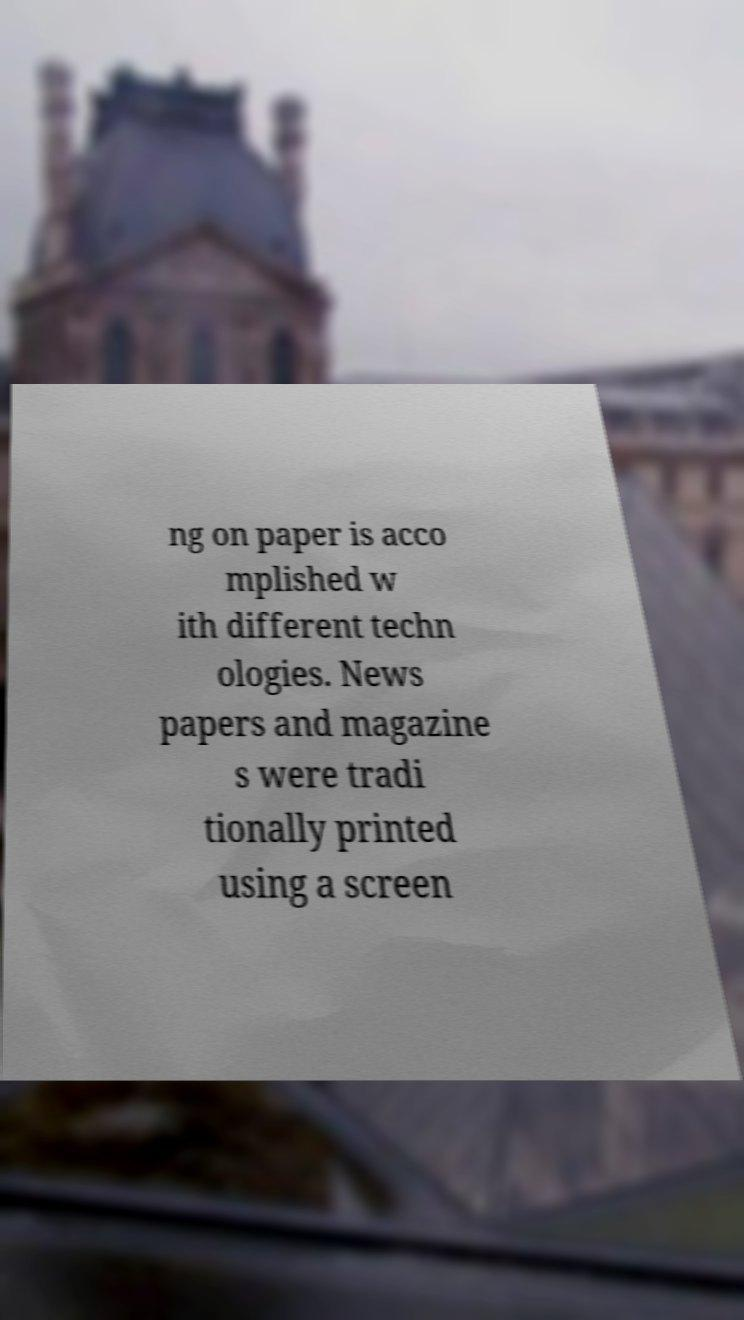There's text embedded in this image that I need extracted. Can you transcribe it verbatim? ng on paper is acco mplished w ith different techn ologies. News papers and magazine s were tradi tionally printed using a screen 